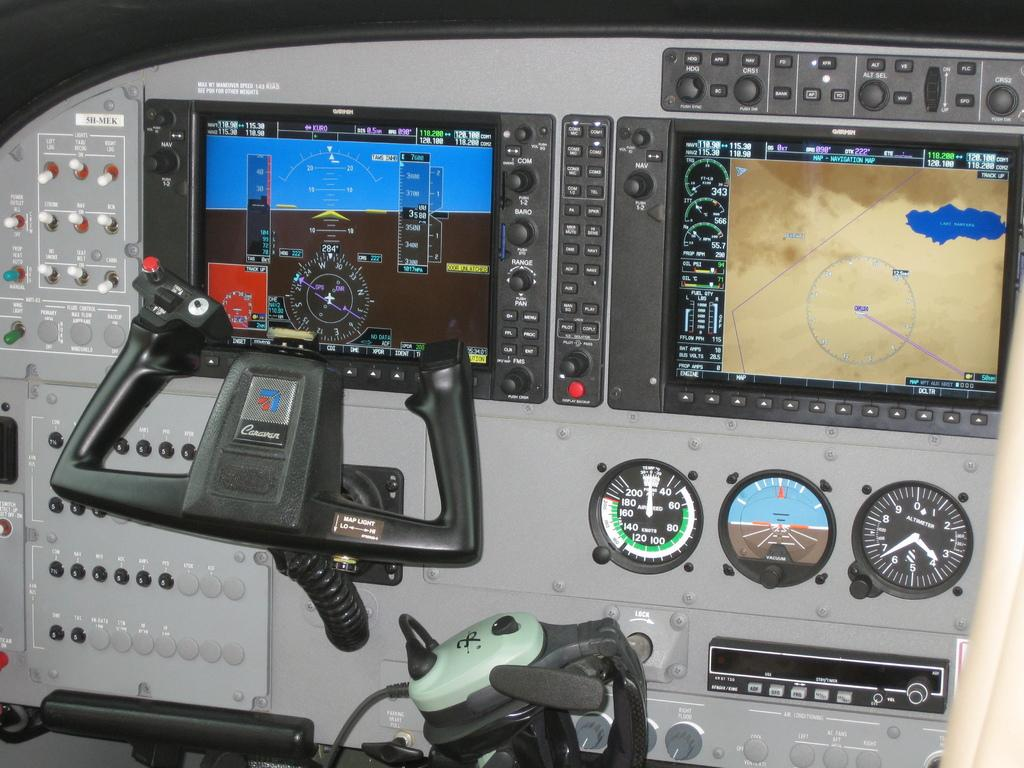Provide a one-sentence caption for the provided image. The aircraft controls say Caravan on the control stick. 